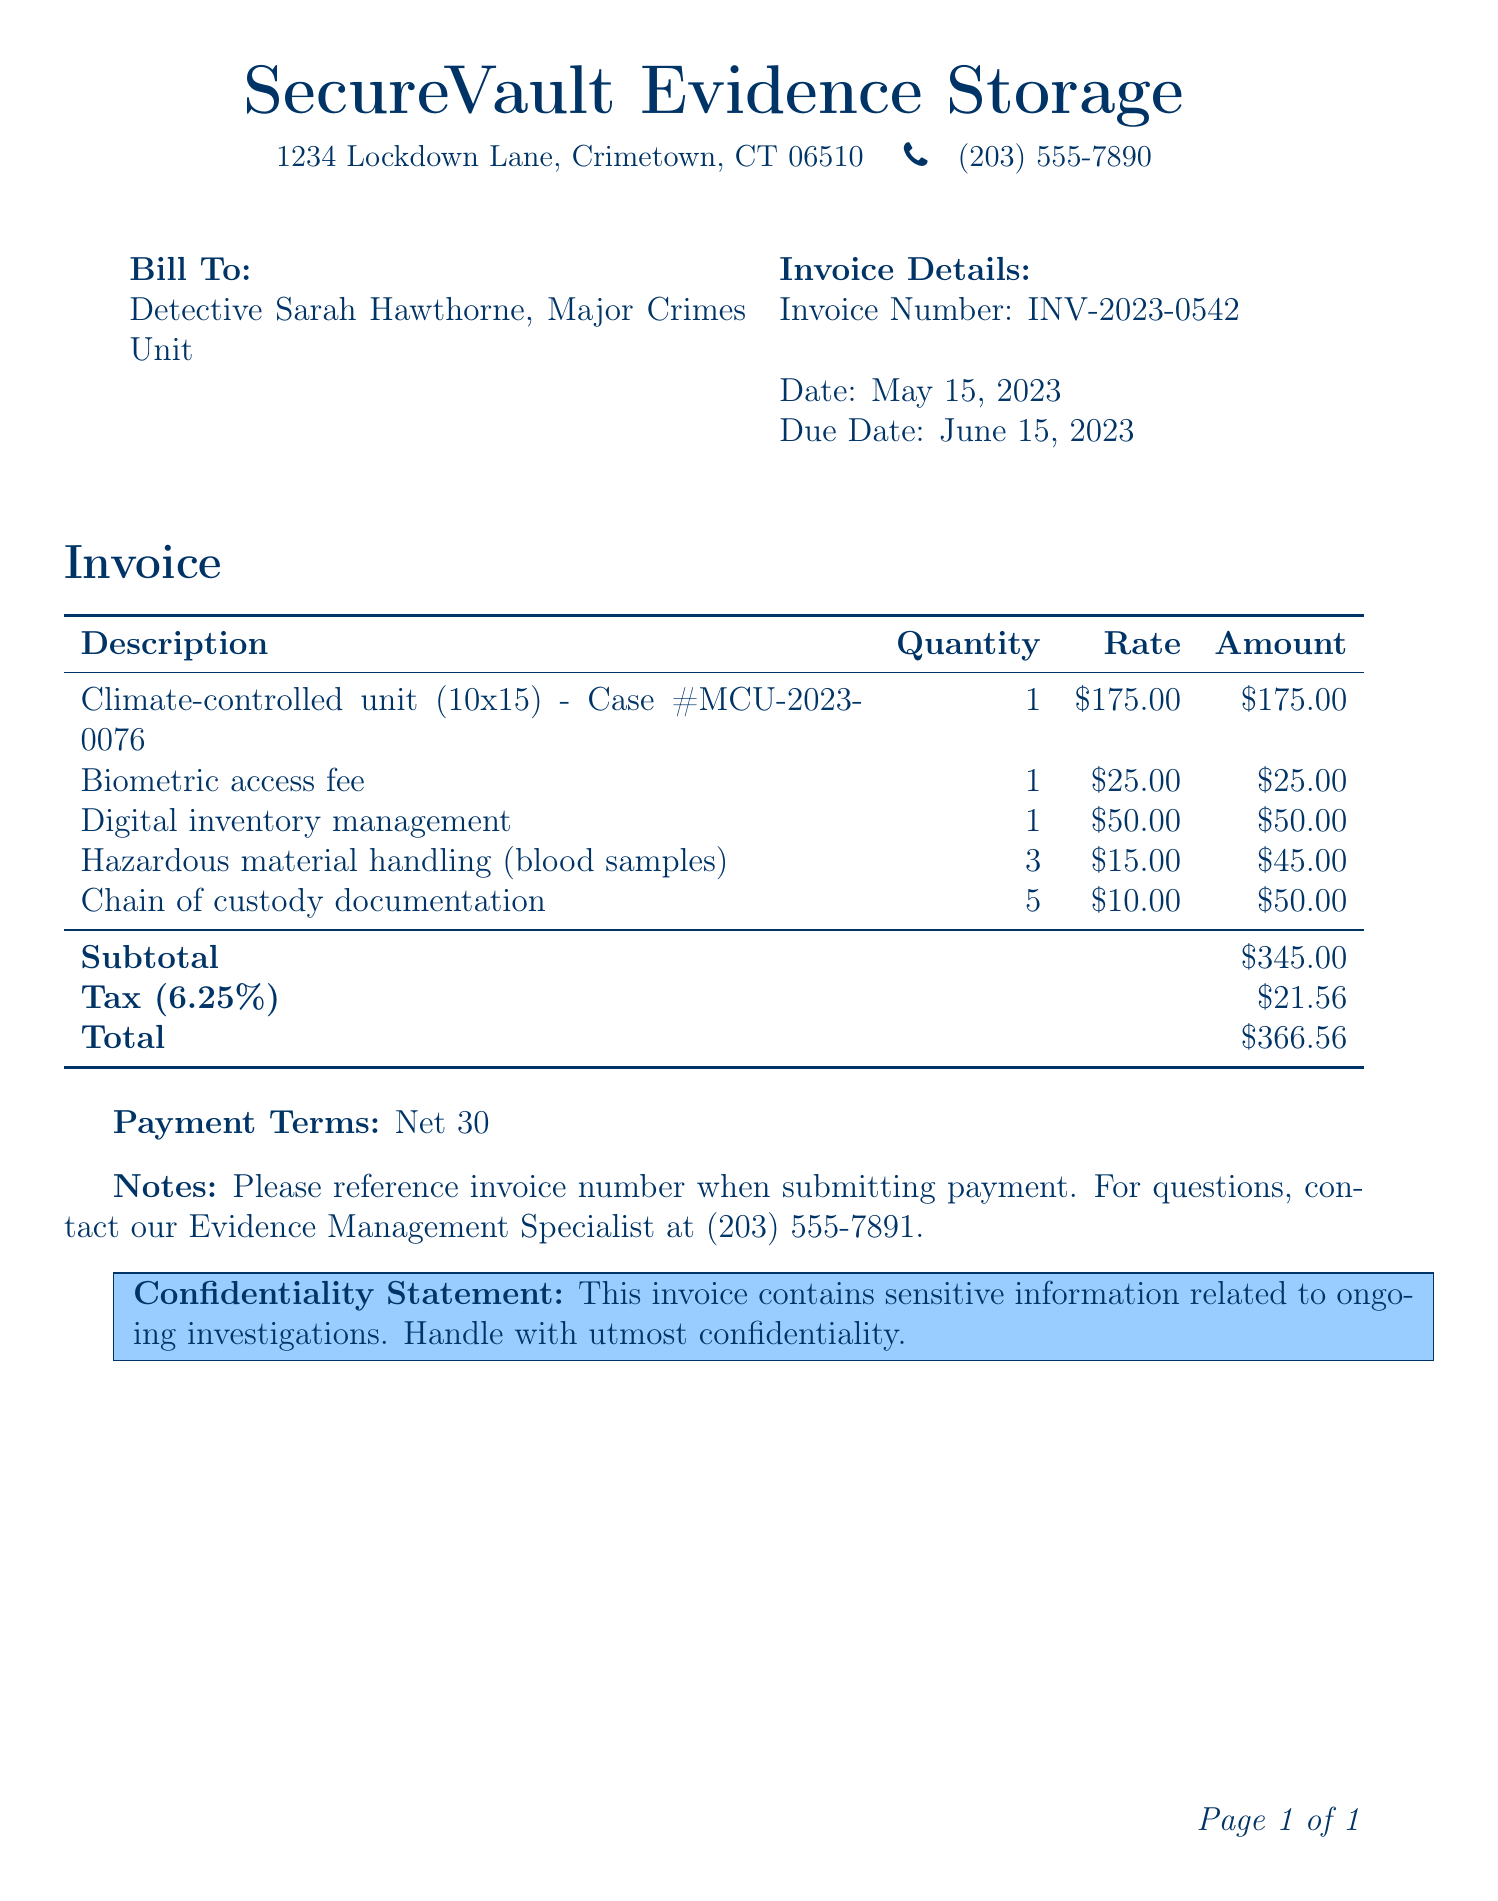what is the invoice number? The invoice number is a unique identifier for the invoice provided in the document, which is INV-2023-0542.
Answer: INV-2023-0542 what is the address of the secure storage facility? The address is provided at the top of the document to identify the location of SecureVault Evidence Storage, which is 1234 Lockdown Lane, Crimetown, CT 06510.
Answer: 1234 Lockdown Lane, Crimetown, CT 06510 who is the bill addressed to? The bill is specifically addressed to a person involved in the Major Crimes Unit, identified as Detective Sarah Hawthorne.
Answer: Detective Sarah Hawthorne what is the subtotal amount before tax? The subtotal amount is calculated by summing the amounts of all listed services before applying tax, which is $345.00.
Answer: $345.00 what is the due date for this invoice? The due date is specified in the document for payment submission, which is June 15, 2023.
Answer: June 15, 2023 how many hazardous material handling items are charged? The document lists the quantity of hazardous material handling items as 3.
Answer: 3 what is the total amount due including tax? The total amount due is provided after tax is added to the subtotal, which is $366.56.
Answer: $366.56 what is the tax rate applied in this invoice? The tax rate applied in this invoice is specified as 6.25%.
Answer: 6.25% what are the payment terms stated in the document? The payment terms indicate the timeframe within which payment should be cleared, specifically noted as Net 30.
Answer: Net 30 